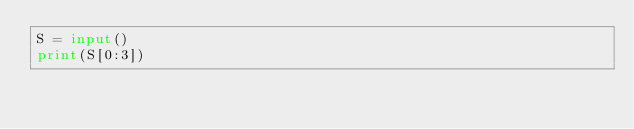<code> <loc_0><loc_0><loc_500><loc_500><_Python_>S = input()
print(S[0:3])</code> 